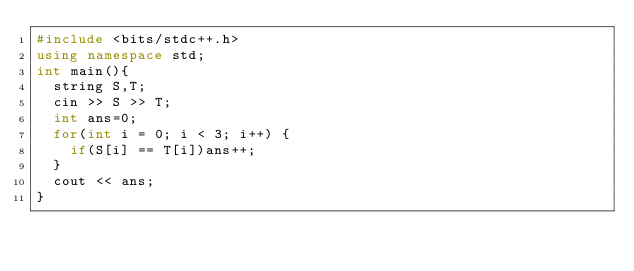<code> <loc_0><loc_0><loc_500><loc_500><_C++_>#include <bits/stdc++.h>
using namespace std;
int main(){
  string S,T;
  cin >> S >> T;
  int ans=0;
  for(int i = 0; i < 3; i++) {
    if(S[i] == T[i])ans++;
  }
  cout << ans;
}</code> 